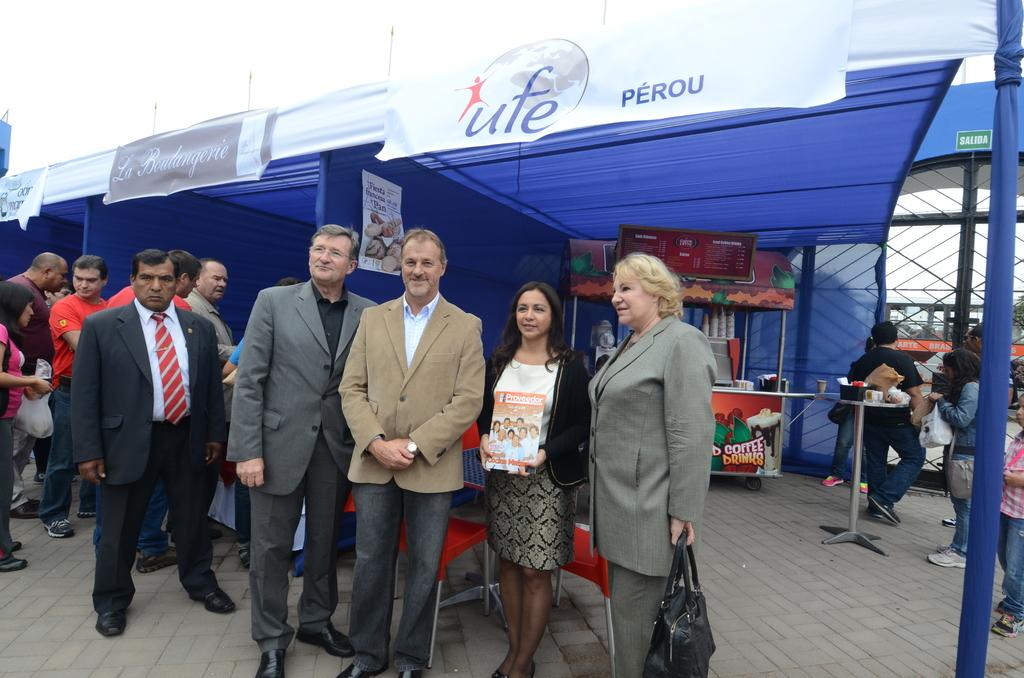What are the people in the image doing? The persons standing on the ground in the image are likely engaged in some activity or gathering. What can be seen beneath the people's feet? The ground is visible in the image. What type of structure can be seen in the image? There is a blue and white colored tent in the image. What type of establishment is present in the image? There is a store in the image. How many people are present in the image? There are other persons in the image besides the ones standing on the ground. What is visible in the background of the image? The sky is visible in the background of the image. Can you tell me how many beasts are present in the image? There are no beasts present in the image; it features people, a tent, a store, and the sky. 